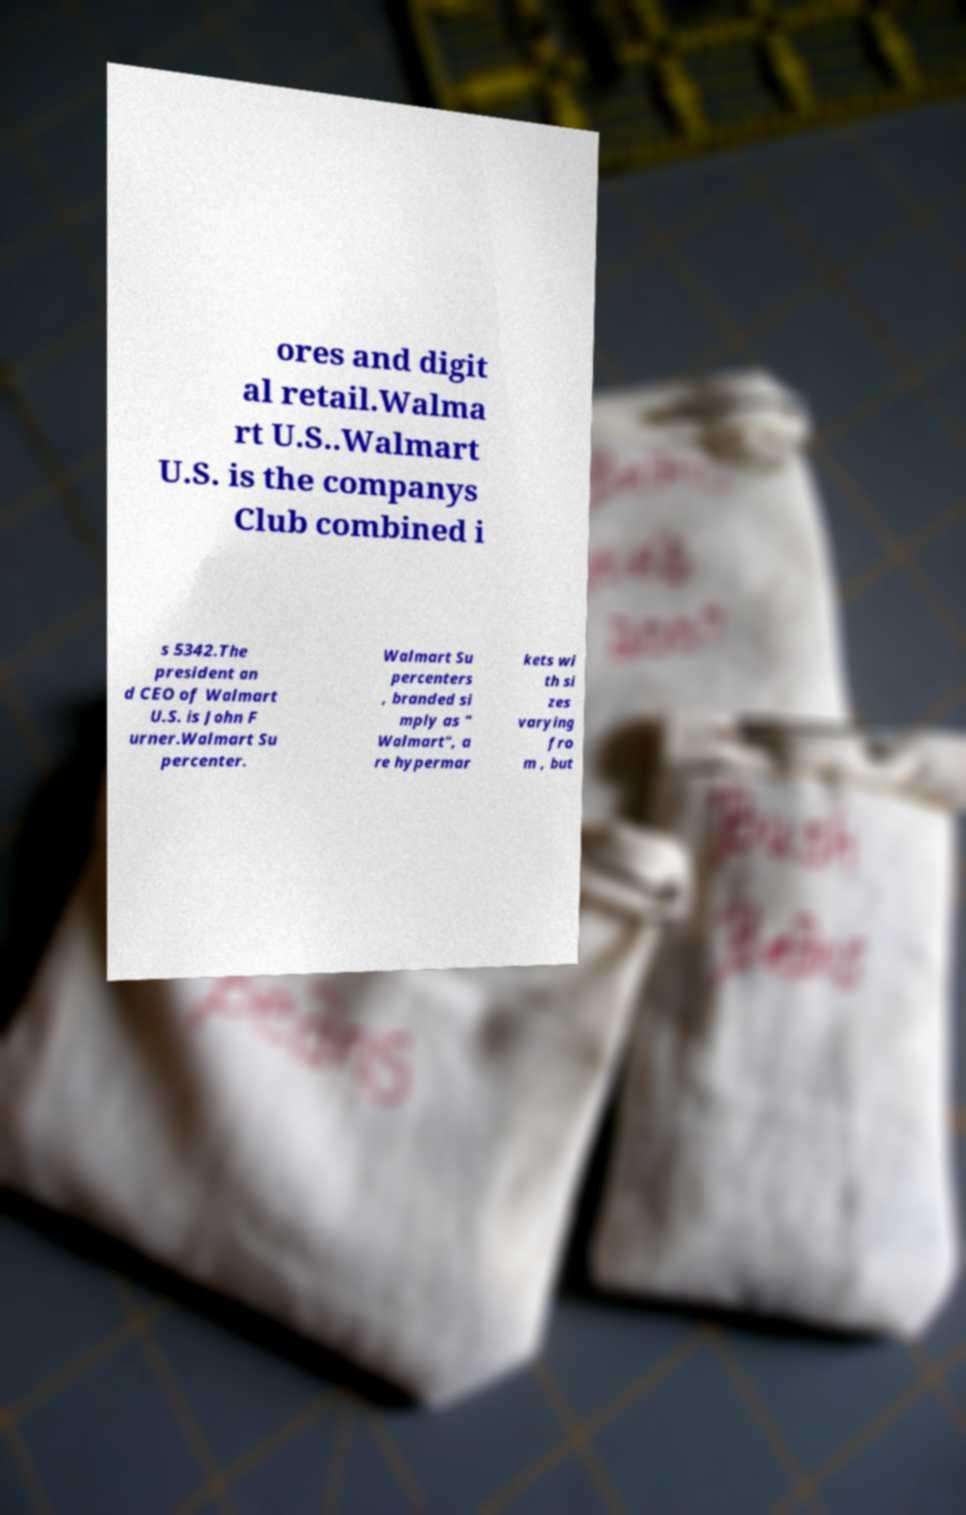Can you read and provide the text displayed in the image?This photo seems to have some interesting text. Can you extract and type it out for me? ores and digit al retail.Walma rt U.S..Walmart U.S. is the companys Club combined i s 5342.The president an d CEO of Walmart U.S. is John F urner.Walmart Su percenter. Walmart Su percenters , branded si mply as " Walmart", a re hypermar kets wi th si zes varying fro m , but 